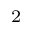Convert formula to latex. <formula><loc_0><loc_0><loc_500><loc_500>^ { 2 }</formula> 